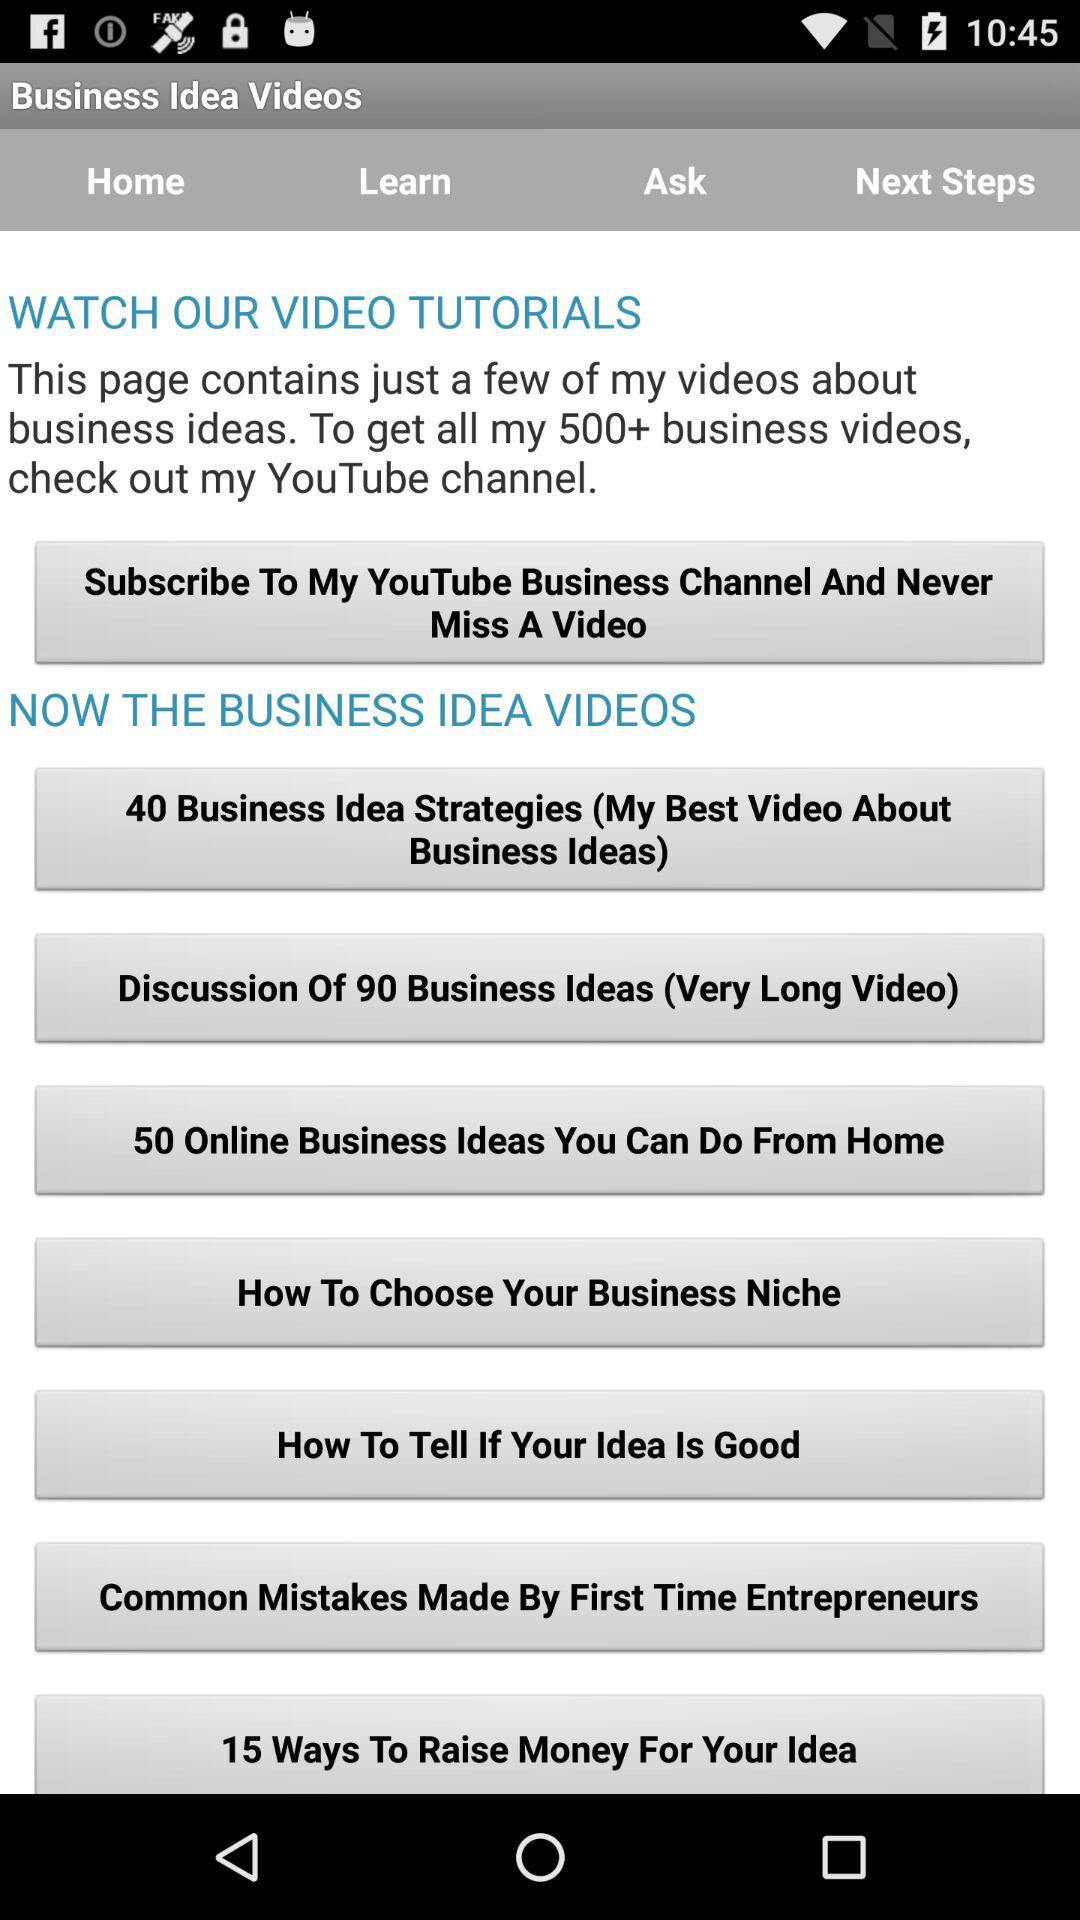How many videos are in the 'Business Idea Videos' section?
Answer the question using a single word or phrase. 7 